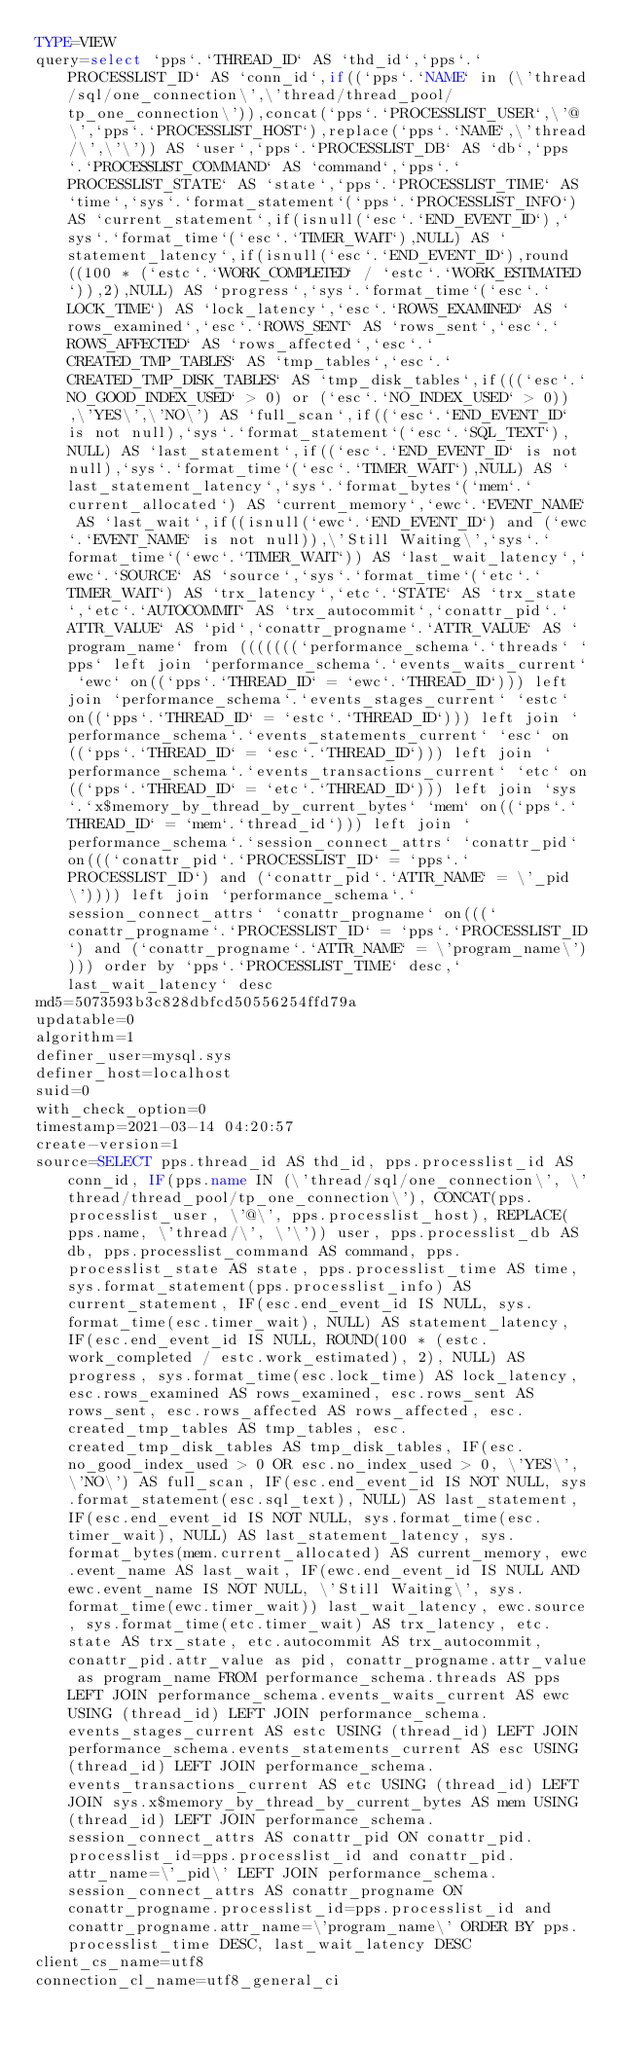<code> <loc_0><loc_0><loc_500><loc_500><_VisualBasic_>TYPE=VIEW
query=select `pps`.`THREAD_ID` AS `thd_id`,`pps`.`PROCESSLIST_ID` AS `conn_id`,if((`pps`.`NAME` in (\'thread/sql/one_connection\',\'thread/thread_pool/tp_one_connection\')),concat(`pps`.`PROCESSLIST_USER`,\'@\',`pps`.`PROCESSLIST_HOST`),replace(`pps`.`NAME`,\'thread/\',\'\')) AS `user`,`pps`.`PROCESSLIST_DB` AS `db`,`pps`.`PROCESSLIST_COMMAND` AS `command`,`pps`.`PROCESSLIST_STATE` AS `state`,`pps`.`PROCESSLIST_TIME` AS `time`,`sys`.`format_statement`(`pps`.`PROCESSLIST_INFO`) AS `current_statement`,if(isnull(`esc`.`END_EVENT_ID`),`sys`.`format_time`(`esc`.`TIMER_WAIT`),NULL) AS `statement_latency`,if(isnull(`esc`.`END_EVENT_ID`),round((100 * (`estc`.`WORK_COMPLETED` / `estc`.`WORK_ESTIMATED`)),2),NULL) AS `progress`,`sys`.`format_time`(`esc`.`LOCK_TIME`) AS `lock_latency`,`esc`.`ROWS_EXAMINED` AS `rows_examined`,`esc`.`ROWS_SENT` AS `rows_sent`,`esc`.`ROWS_AFFECTED` AS `rows_affected`,`esc`.`CREATED_TMP_TABLES` AS `tmp_tables`,`esc`.`CREATED_TMP_DISK_TABLES` AS `tmp_disk_tables`,if(((`esc`.`NO_GOOD_INDEX_USED` > 0) or (`esc`.`NO_INDEX_USED` > 0)),\'YES\',\'NO\') AS `full_scan`,if((`esc`.`END_EVENT_ID` is not null),`sys`.`format_statement`(`esc`.`SQL_TEXT`),NULL) AS `last_statement`,if((`esc`.`END_EVENT_ID` is not null),`sys`.`format_time`(`esc`.`TIMER_WAIT`),NULL) AS `last_statement_latency`,`sys`.`format_bytes`(`mem`.`current_allocated`) AS `current_memory`,`ewc`.`EVENT_NAME` AS `last_wait`,if((isnull(`ewc`.`END_EVENT_ID`) and (`ewc`.`EVENT_NAME` is not null)),\'Still Waiting\',`sys`.`format_time`(`ewc`.`TIMER_WAIT`)) AS `last_wait_latency`,`ewc`.`SOURCE` AS `source`,`sys`.`format_time`(`etc`.`TIMER_WAIT`) AS `trx_latency`,`etc`.`STATE` AS `trx_state`,`etc`.`AUTOCOMMIT` AS `trx_autocommit`,`conattr_pid`.`ATTR_VALUE` AS `pid`,`conattr_progname`.`ATTR_VALUE` AS `program_name` from (((((((`performance_schema`.`threads` `pps` left join `performance_schema`.`events_waits_current` `ewc` on((`pps`.`THREAD_ID` = `ewc`.`THREAD_ID`))) left join `performance_schema`.`events_stages_current` `estc` on((`pps`.`THREAD_ID` = `estc`.`THREAD_ID`))) left join `performance_schema`.`events_statements_current` `esc` on((`pps`.`THREAD_ID` = `esc`.`THREAD_ID`))) left join `performance_schema`.`events_transactions_current` `etc` on((`pps`.`THREAD_ID` = `etc`.`THREAD_ID`))) left join `sys`.`x$memory_by_thread_by_current_bytes` `mem` on((`pps`.`THREAD_ID` = `mem`.`thread_id`))) left join `performance_schema`.`session_connect_attrs` `conattr_pid` on(((`conattr_pid`.`PROCESSLIST_ID` = `pps`.`PROCESSLIST_ID`) and (`conattr_pid`.`ATTR_NAME` = \'_pid\')))) left join `performance_schema`.`session_connect_attrs` `conattr_progname` on(((`conattr_progname`.`PROCESSLIST_ID` = `pps`.`PROCESSLIST_ID`) and (`conattr_progname`.`ATTR_NAME` = \'program_name\')))) order by `pps`.`PROCESSLIST_TIME` desc,`last_wait_latency` desc
md5=5073593b3c828dbfcd50556254ffd79a
updatable=0
algorithm=1
definer_user=mysql.sys
definer_host=localhost
suid=0
with_check_option=0
timestamp=2021-03-14 04:20:57
create-version=1
source=SELECT pps.thread_id AS thd_id, pps.processlist_id AS conn_id, IF(pps.name IN (\'thread/sql/one_connection\', \'thread/thread_pool/tp_one_connection\'), CONCAT(pps.processlist_user, \'@\', pps.processlist_host), REPLACE(pps.name, \'thread/\', \'\')) user, pps.processlist_db AS db, pps.processlist_command AS command, pps.processlist_state AS state, pps.processlist_time AS time, sys.format_statement(pps.processlist_info) AS current_statement, IF(esc.end_event_id IS NULL, sys.format_time(esc.timer_wait), NULL) AS statement_latency, IF(esc.end_event_id IS NULL, ROUND(100 * (estc.work_completed / estc.work_estimated), 2), NULL) AS progress, sys.format_time(esc.lock_time) AS lock_latency, esc.rows_examined AS rows_examined, esc.rows_sent AS rows_sent, esc.rows_affected AS rows_affected, esc.created_tmp_tables AS tmp_tables, esc.created_tmp_disk_tables AS tmp_disk_tables, IF(esc.no_good_index_used > 0 OR esc.no_index_used > 0, \'YES\', \'NO\') AS full_scan, IF(esc.end_event_id IS NOT NULL, sys.format_statement(esc.sql_text), NULL) AS last_statement, IF(esc.end_event_id IS NOT NULL, sys.format_time(esc.timer_wait), NULL) AS last_statement_latency, sys.format_bytes(mem.current_allocated) AS current_memory, ewc.event_name AS last_wait, IF(ewc.end_event_id IS NULL AND ewc.event_name IS NOT NULL, \'Still Waiting\', sys.format_time(ewc.timer_wait)) last_wait_latency, ewc.source, sys.format_time(etc.timer_wait) AS trx_latency, etc.state AS trx_state, etc.autocommit AS trx_autocommit, conattr_pid.attr_value as pid, conattr_progname.attr_value as program_name FROM performance_schema.threads AS pps LEFT JOIN performance_schema.events_waits_current AS ewc USING (thread_id) LEFT JOIN performance_schema.events_stages_current AS estc USING (thread_id) LEFT JOIN performance_schema.events_statements_current AS esc USING (thread_id) LEFT JOIN performance_schema.events_transactions_current AS etc USING (thread_id) LEFT JOIN sys.x$memory_by_thread_by_current_bytes AS mem USING (thread_id) LEFT JOIN performance_schema.session_connect_attrs AS conattr_pid ON conattr_pid.processlist_id=pps.processlist_id and conattr_pid.attr_name=\'_pid\' LEFT JOIN performance_schema.session_connect_attrs AS conattr_progname ON conattr_progname.processlist_id=pps.processlist_id and conattr_progname.attr_name=\'program_name\' ORDER BY pps.processlist_time DESC, last_wait_latency DESC
client_cs_name=utf8
connection_cl_name=utf8_general_ci</code> 